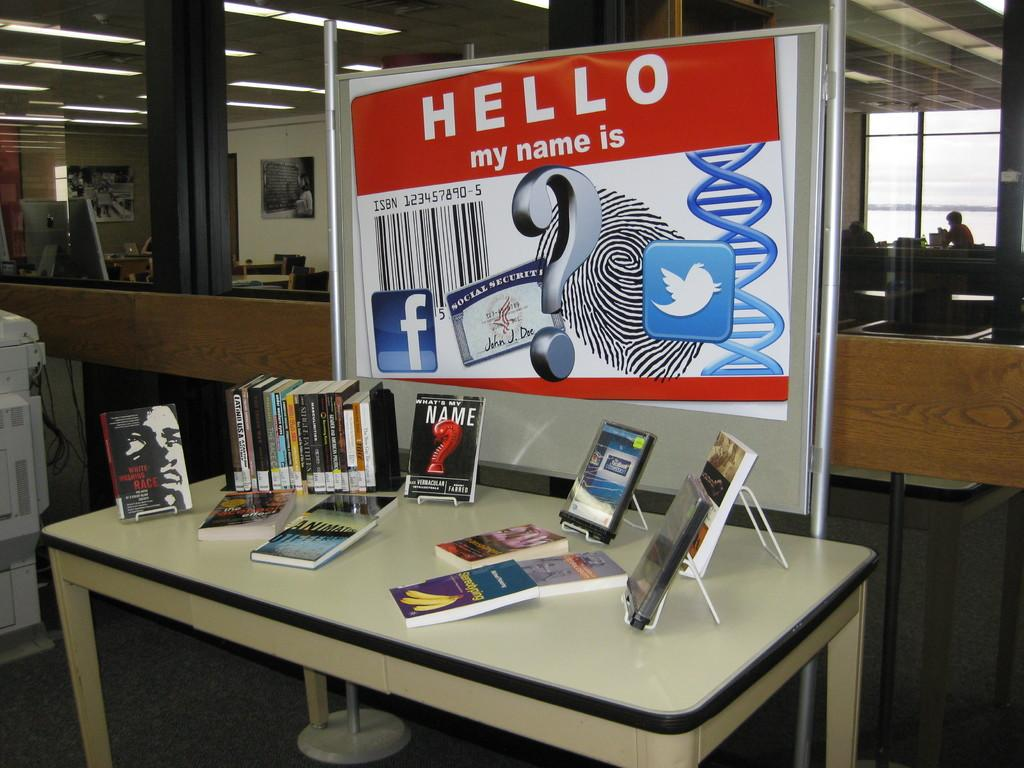Provide a one-sentence caption for the provided image. A display of books below a sign that says "Hello my name is". 